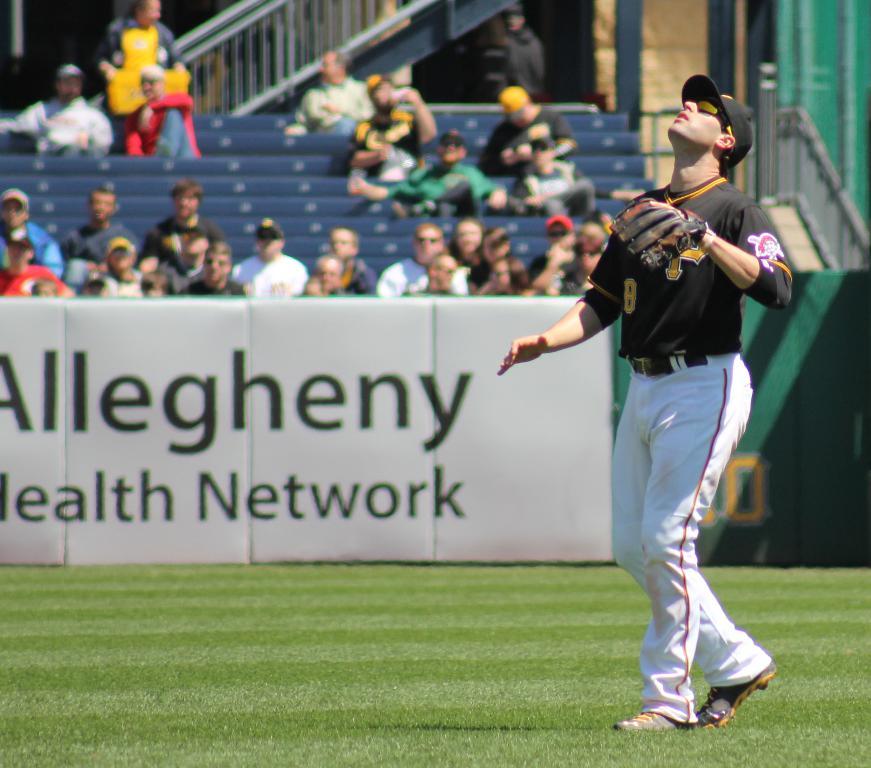What work is allegheny health presenting?
Your response must be concise. Network. 